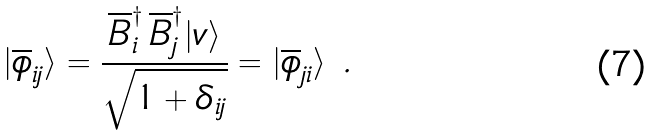Convert formula to latex. <formula><loc_0><loc_0><loc_500><loc_500>| \overline { \phi } _ { i j } \rangle = \frac { \overline { B } _ { i } ^ { \dag } \, \overline { B } _ { j } ^ { \dag } | v \rangle } { \sqrt { 1 + \delta _ { i j } } } = | \overline { \phi } _ { j i } \rangle \ .</formula> 